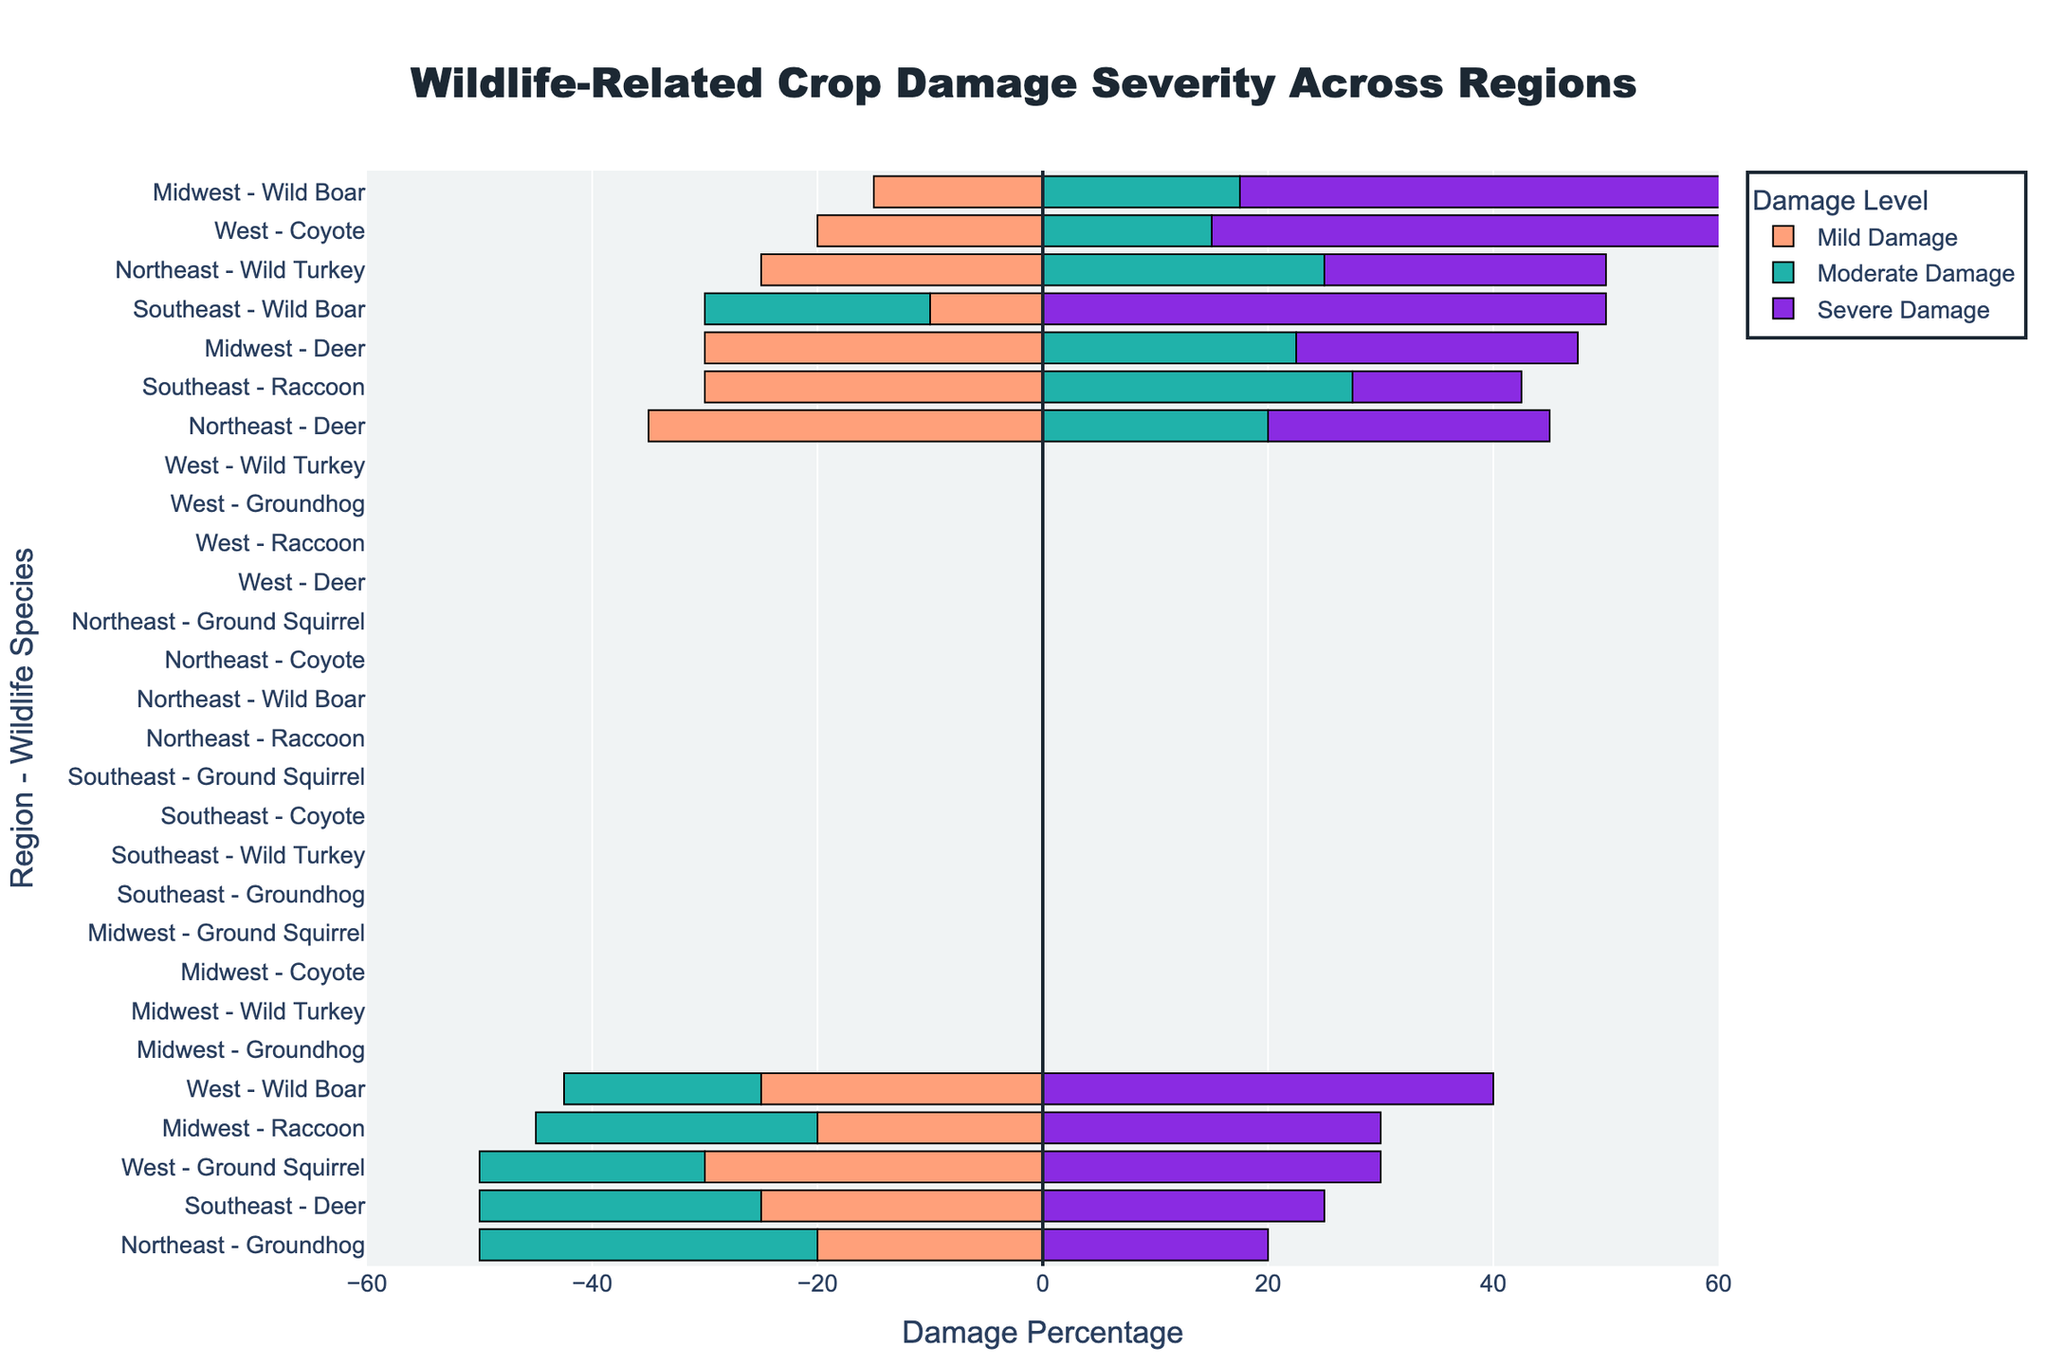What region has the highest percentage of severe damage caused by wild boars? Identify the severe damage values for wild boars in each region. For the Midwest, it's 50%; for the Southeast, it's 50%; and for the West, it's 40%. Both the Midwest and Southeast have the highest percentage of severe damage by wild boars.
Answer: Midwest and Southeast Compare the severity of damage caused by raccoons in the Midwest and Southeast regions. Which region has higher severe damage? Look at the severe damage values for raccoons: Midwest has 30% and Southeast has 15%. The Midwest has higher severe damage from raccoons than the Southeast.
Answer: Midwest What is the total mild damage from ground squirrels in the West? Mild damage for ground squirrels in the West is 30%. The sum is simply 30% since it is only one value.
Answer: 30% Which wildlife species in the Northeast causes the highest moderate damage? Look at the moderate damage percentages in the Northeast: Deer (40%), Groundhog (60%), and Wild Turkey (50%). Groundhog has the highest moderate damage.
Answer: Groundhog Compare the total damage (mild + moderate + severe) caused by deer in the Midwest and Northeast regions. Which region experiences more damage? For the Midwest, deer cause 30% (mild) + 45% (moderate) + 25% (severe) = 100%. For the Northeast, deer cause 35% (mild) + 40% (moderate) + 25% (severe) = 100%. Both regions experience the same total damage from deer.
Answer: Both regions experience the same damage What is the difference in severe damage caused by wild boars between the Southeast and the West? Identify the severe damage by wild boars in the Southeast (50%) and in the West (40%). The difference is 50% - 40% = 10%.
Answer: 10% Which region has the least moderate damage caused by coyotes? Coyotes are only present in the West region where they cause 30% moderate damage. Since there is no other region to compare, the least moderate damage remains 30% in the West.
Answer: West For each region, which wildlife species causes the highest mild damage? Identify mild damage values for each region: Midwest - Deer (30%), Southeast - Raccoon (30%), Northeast - Deer (35%), West - Ground Squirrel (30%). So, the highest mild damage per region is Deer in Midwest, Raccoon in Southeast, Deer in Northeast, and Ground Squirrel in West.
Answer: Midwest: Deer, Southeast: Raccoon, Northeast: Deer, West: Ground Squirrel Summarize the overall mild damage caused by wild turkeys in all regions. Mild damage by wild turkeys is only recorded in the Northeast at 25%. Since no other regions have wild turkeys, the total mild damage is simply 25%.
Answer: 25% 